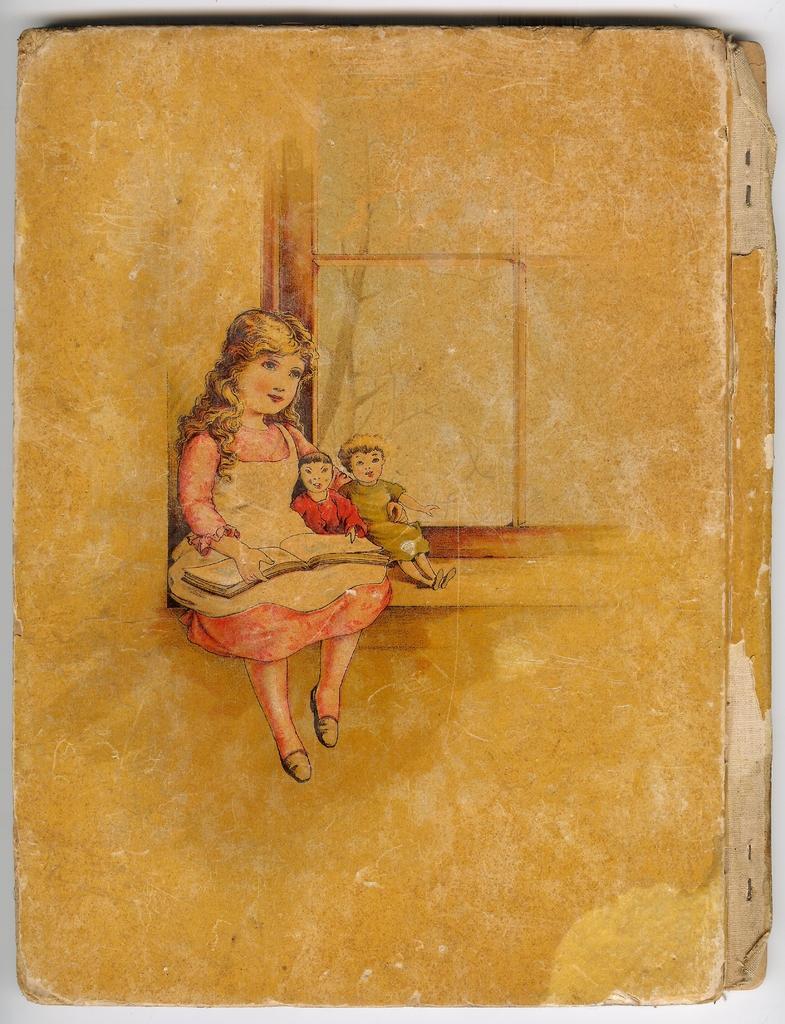In one or two sentences, can you explain what this image depicts? In this picture we can see a cardboard sheet with a painting of a girl and two kids. 